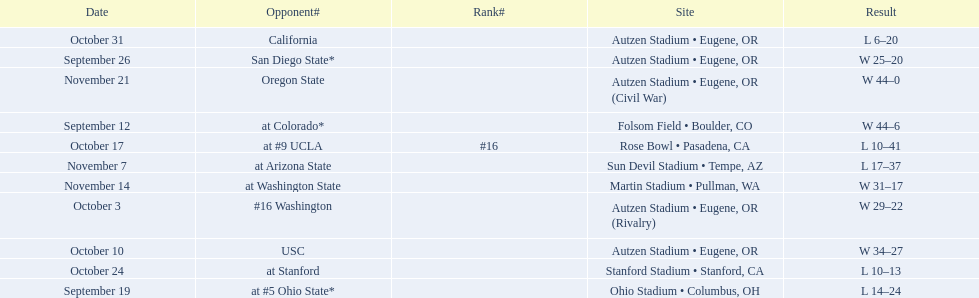What is the number of away games ? 6. 